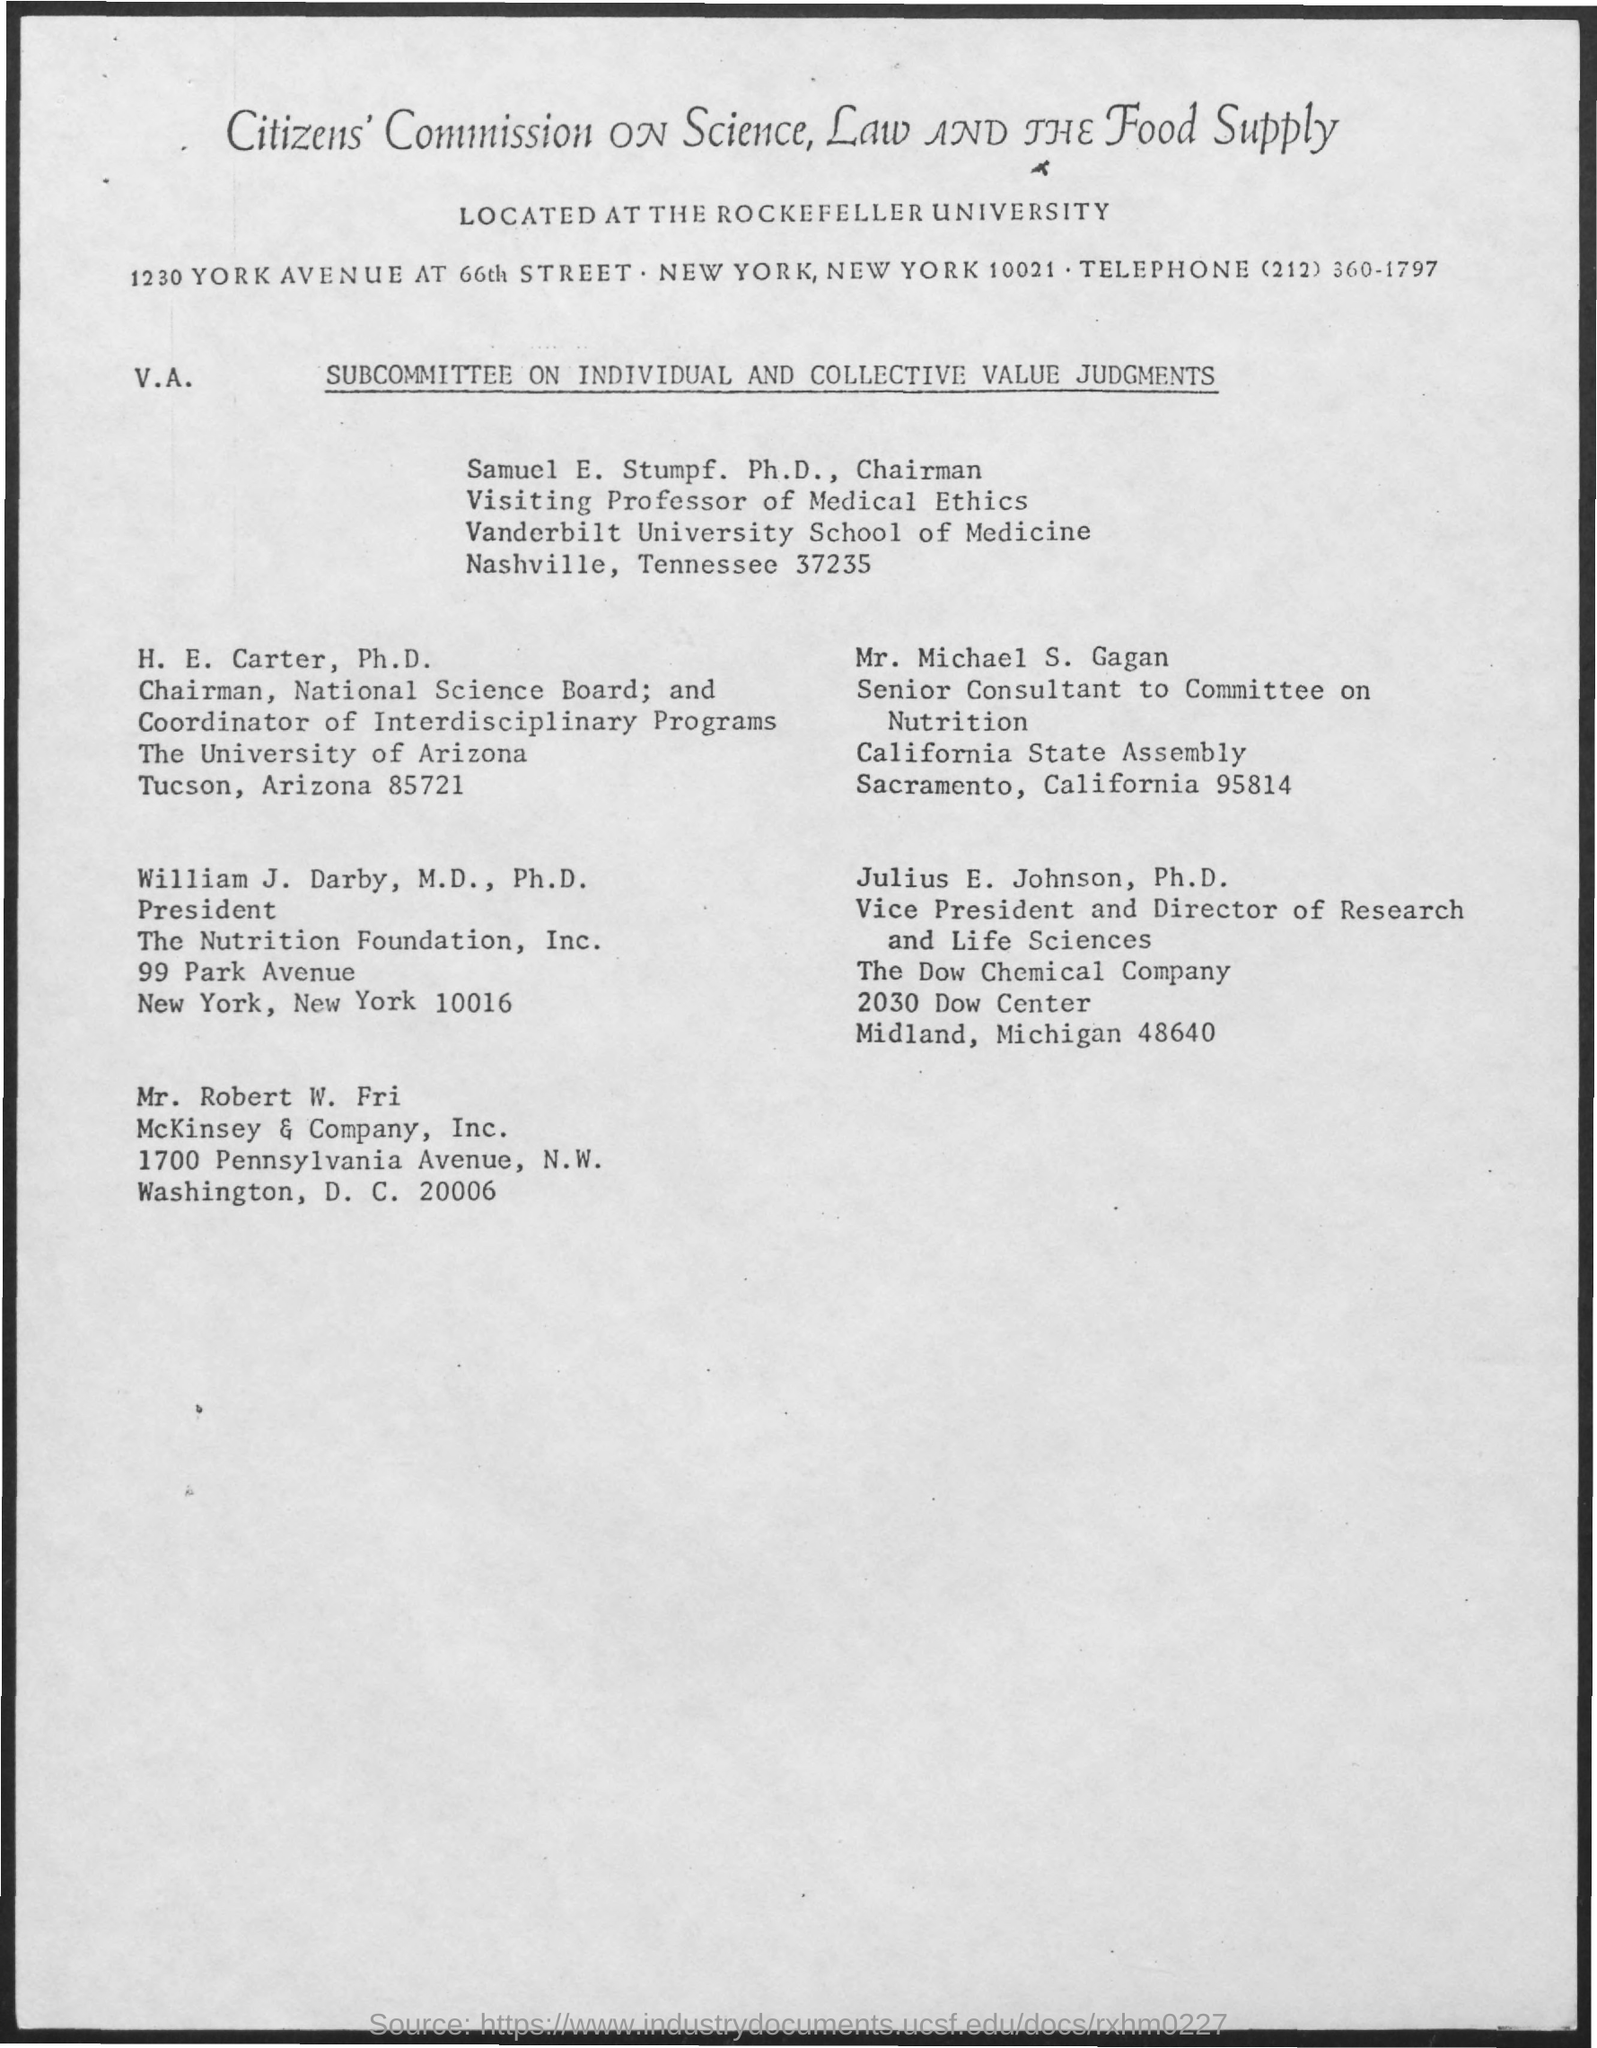What is the telephone no. mentioned in the given page ?
Your answer should be compact. (212) 360-1797. To which university h.e. carter belongs to ?
Your answer should be compact. The university of arizona. What is the designation of william j darby mentioned ?
Your answer should be compact. President. What is the designation of mr. michael s. gagan ?
Offer a very short reply. Senior Consultant to Committee on Nutrition. 